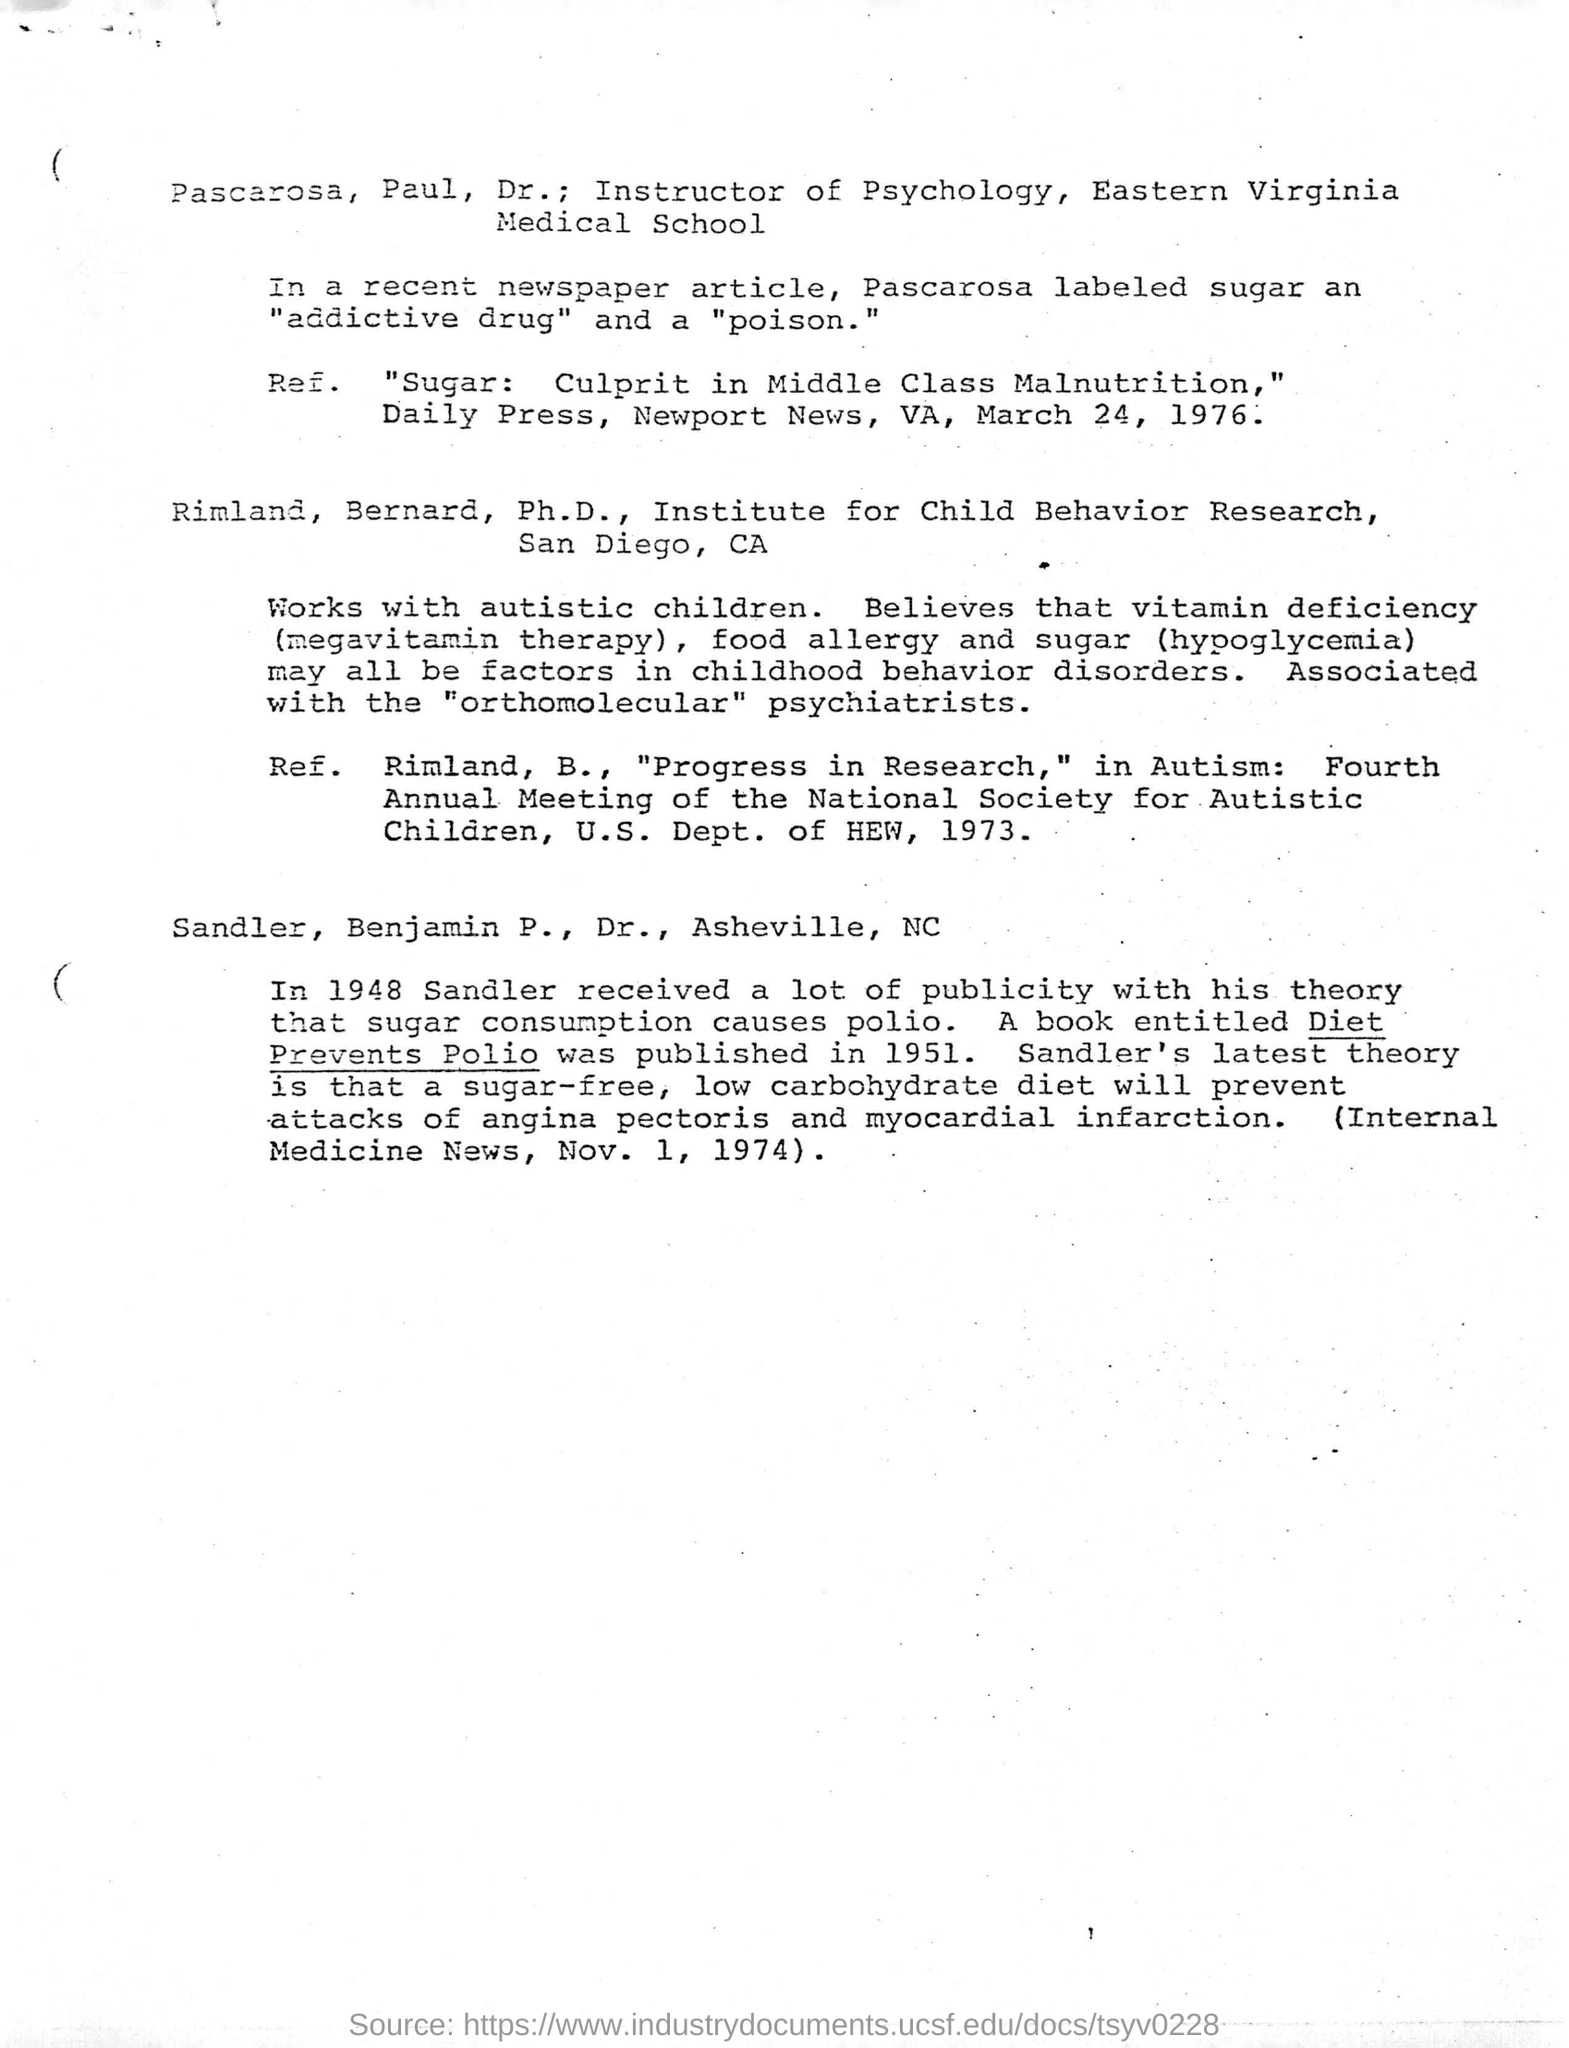Who is Pascarosa, Paul , Dr. ?
Your response must be concise. Instructor of Psychology, Eastern Virginia Medical School. What did Pascarosa Labeled sugar in a recent newspaper article?
Make the answer very short. An "addictive drug" and a "poison.". Who received publicity with theory that sugar consumption causes polio?
Provide a succinct answer. Sandler,  Benjamin P. , Dr. , Asheville, NC. In which year , a book entitled Diet Prevents Polio was published?
Your response must be concise. 1951. 